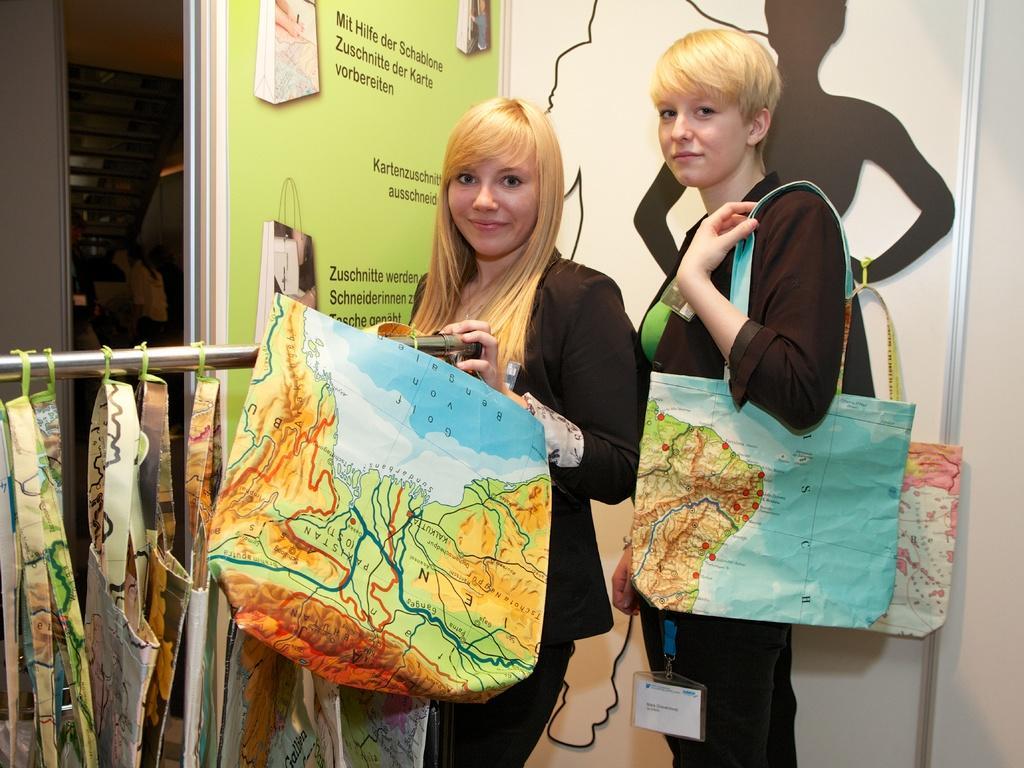Describe this image in one or two sentences. In this picture there were two women in black blazers and black pants. there were holding bags and maps printed on them. To the left bottom there were bags hanging to a pole, to the left top there is a room filled with trays. In the background there is a wall, some pictures, bags and text printed on it. 